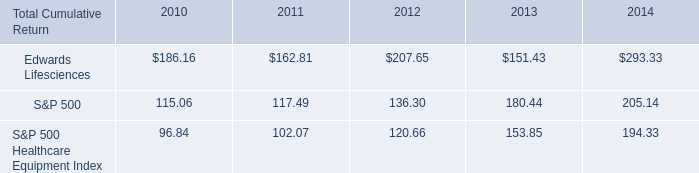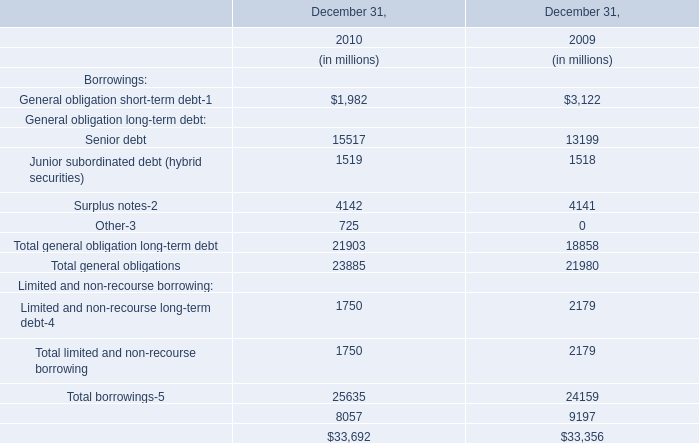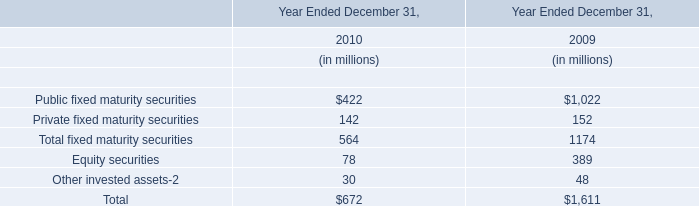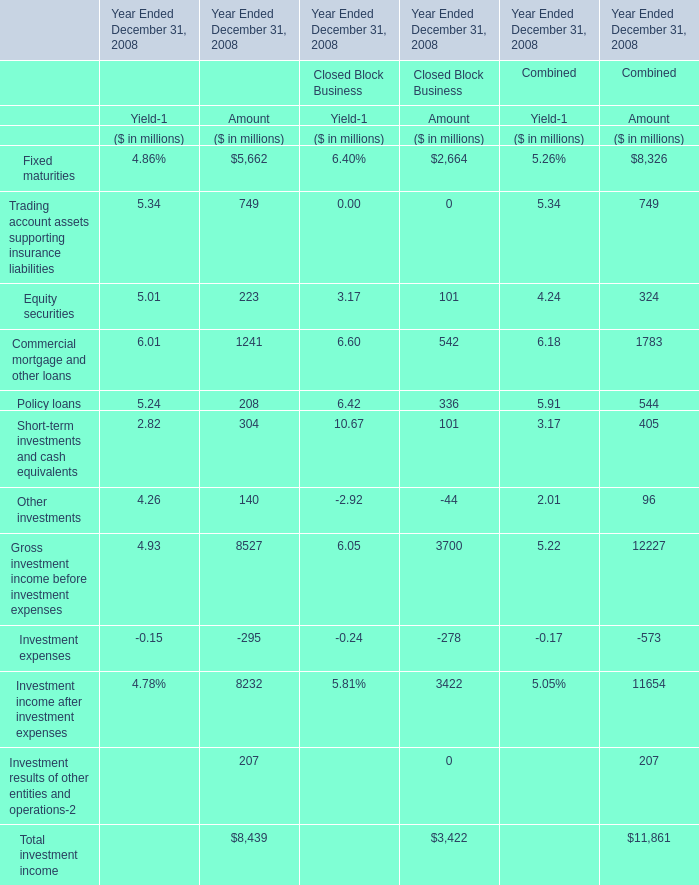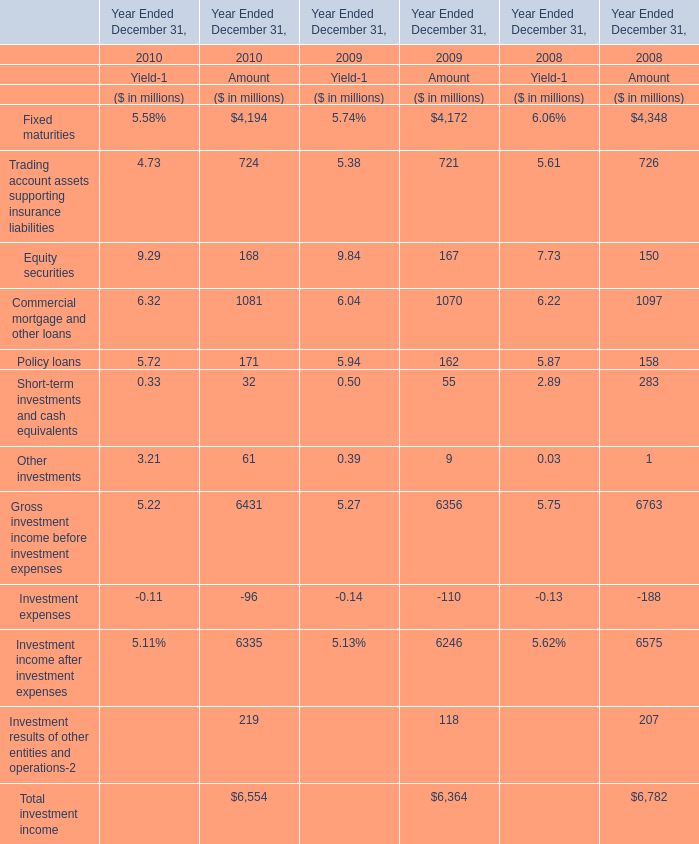Which year Ended December 31 is Amount of Equity securities the highest? 
Answer: 2010. 